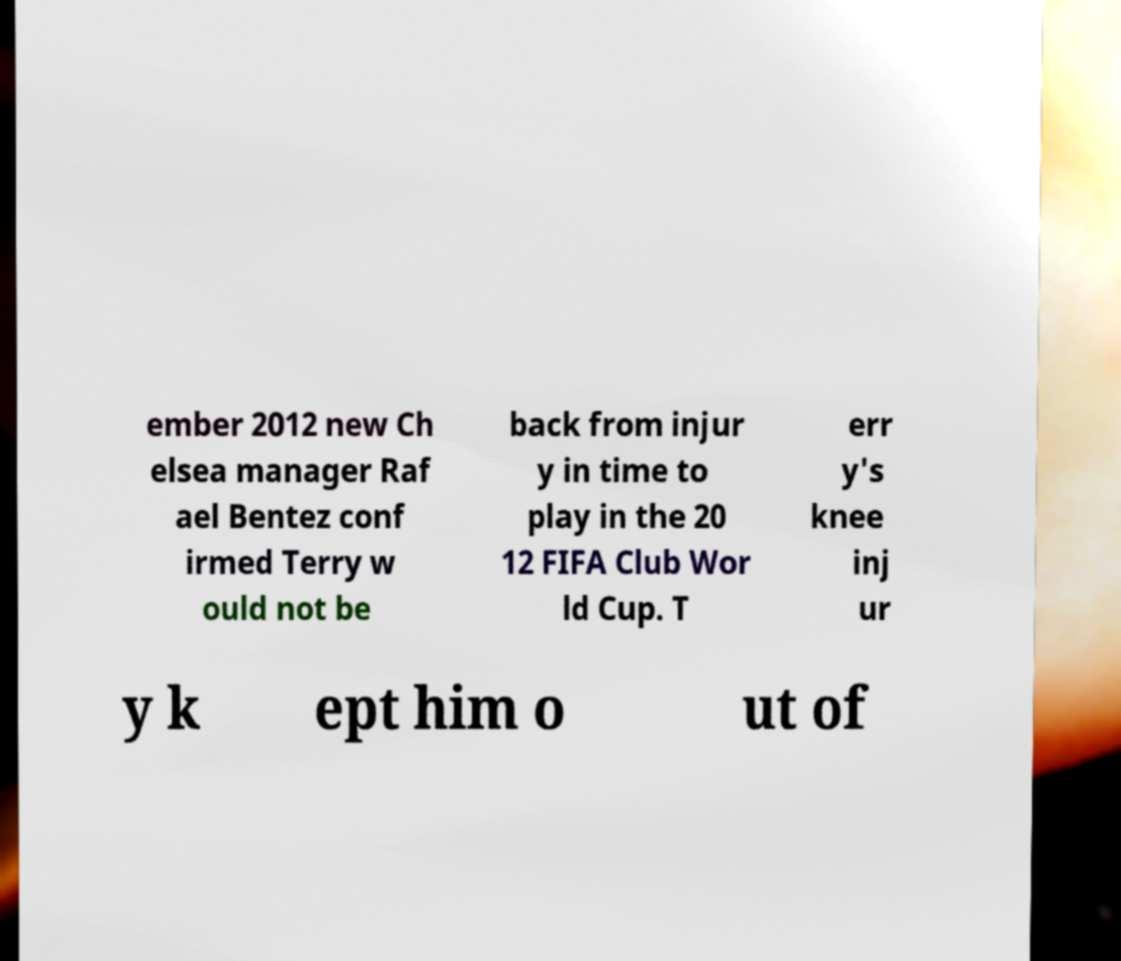Please read and relay the text visible in this image. What does it say? ember 2012 new Ch elsea manager Raf ael Bentez conf irmed Terry w ould not be back from injur y in time to play in the 20 12 FIFA Club Wor ld Cup. T err y's knee inj ur y k ept him o ut of 